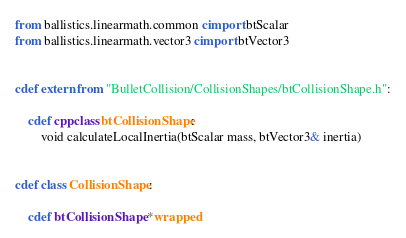<code> <loc_0><loc_0><loc_500><loc_500><_Cython_>from ballistics.linearmath.common cimport btScalar
from ballistics.linearmath.vector3 cimport btVector3


cdef extern from "BulletCollision/CollisionShapes/btCollisionShape.h":

    cdef cppclass btCollisionShape:
        void calculateLocalInertia(btScalar mass, btVector3& inertia)


cdef class CollisionShape:

    cdef btCollisionShape *wrapped
</code> 